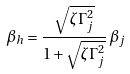Convert formula to latex. <formula><loc_0><loc_0><loc_500><loc_500>\beta _ { h } = \frac { \sqrt { \zeta \Gamma _ { j } ^ { 2 } } } { 1 + \sqrt { \zeta \Gamma _ { j } ^ { 2 } } } \, \beta _ { j }</formula> 